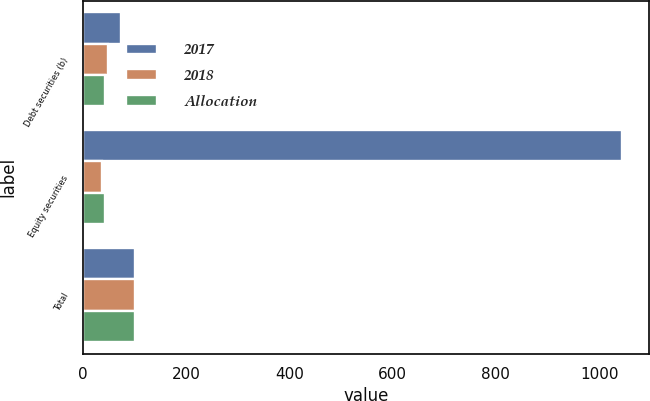Convert chart to OTSL. <chart><loc_0><loc_0><loc_500><loc_500><stacked_bar_chart><ecel><fcel>Debt securities (b)<fcel>Equity securities<fcel>Total<nl><fcel>2017<fcel>74<fcel>1045<fcel>100<nl><fcel>2018<fcel>48<fcel>37<fcel>100<nl><fcel>Allocation<fcel>42<fcel>42<fcel>100<nl></chart> 